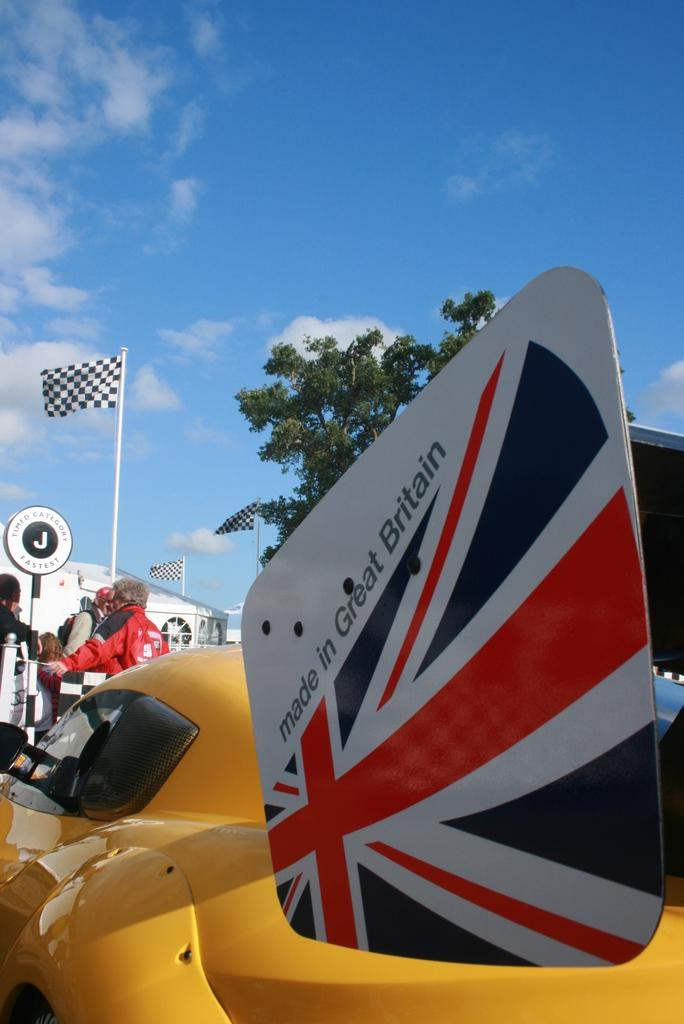<image>
Relay a brief, clear account of the picture shown. A card that says made in Great Britain hangs near a yellow vehicle. 